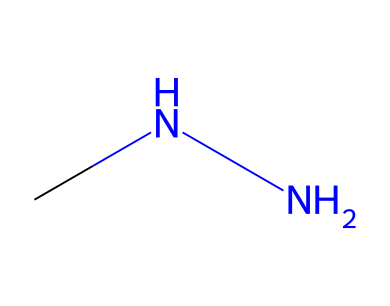What is the total number of atoms in monomethylhydrazine? Examining the SMILES representation "CNN" reveals that there are three atoms: two nitrogen (N) atoms and one carbon (C) atom. Therefore, the total count is 3.
Answer: 3 How many nitrogen atoms are present in monomethylhydrazine? The SMILES representation "CNN" shows two 'N' letters, indicating there are two nitrogen atoms in the structure.
Answer: 2 What type of bonds connect the carbon and nitrogen in monomethylhydrazine? In "CNN," the carbon is bonded to both nitrogen atoms through single bonds. This is inferred from the lack of any symbols indicating double or triple bonds between them.
Answer: single bonds Which functional group is dominant in monomethylhydrazine? The primary functional group observed in the structure is the hydrazine group (-NH-NH-), which is typical for hydrazines. The presence of both nitrogen atoms connected together indicates this functional group.
Answer: hydrazine group What is the molecular formula for monomethylhydrazine? The SMILES "CNN" can be translated into the molecular formula by counting the atoms: C (1) + N (2) + H (6) derived from hydrogens connected to the nitrogen atoms and carbon (alkyl) considering tetravalence. So the formula becomes C2H8N2.
Answer: C2H8N2 How many hydrogen atoms are represented in the structure of monomethylhydrazine? Based on tetravalence, the carbon atom in "CNN" is bonded with three hydrogen atoms and each nitrogen is bonded with two hydrogens; thus, 3 (from carbon) + 2 (from one nitrogen) + 2 (from second nitrogen) results in a total of 8 hydrogen atoms.
Answer: 8 What is the classification of monomethylhydrazine? Monomethylhydrazine is classified as a hydrazine compound due to its structure which includes the hydrazine functional group. This classification is specific because it contains nitrogen-nitrogen bonds.
Answer: hydrazine 